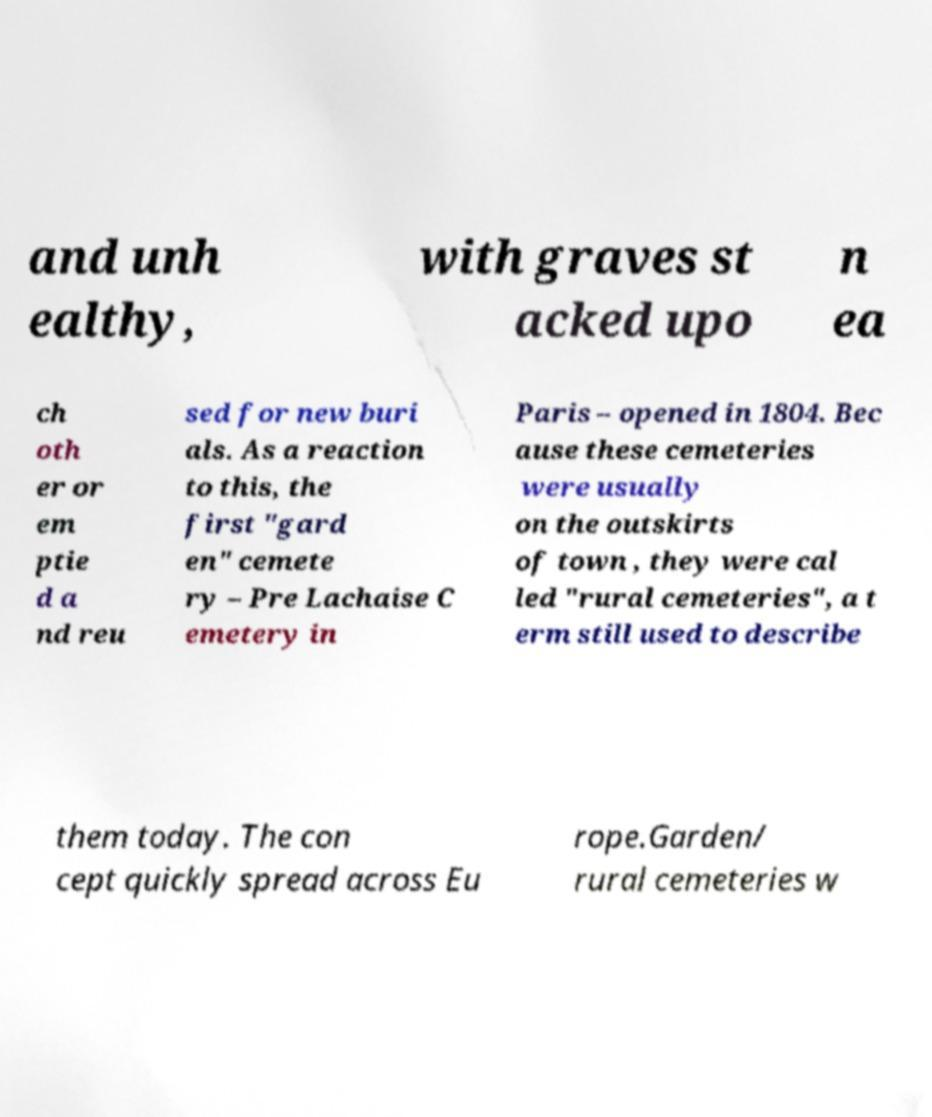What messages or text are displayed in this image? I need them in a readable, typed format. and unh ealthy, with graves st acked upo n ea ch oth er or em ptie d a nd reu sed for new buri als. As a reaction to this, the first "gard en" cemete ry – Pre Lachaise C emetery in Paris – opened in 1804. Bec ause these cemeteries were usually on the outskirts of town , they were cal led "rural cemeteries", a t erm still used to describe them today. The con cept quickly spread across Eu rope.Garden/ rural cemeteries w 